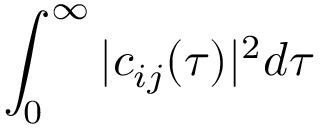Convert formula to latex. <formula><loc_0><loc_0><loc_500><loc_500>\int _ { 0 } ^ { \infty } | c _ { i j } ( \tau ) | ^ { 2 } d \tau</formula> 